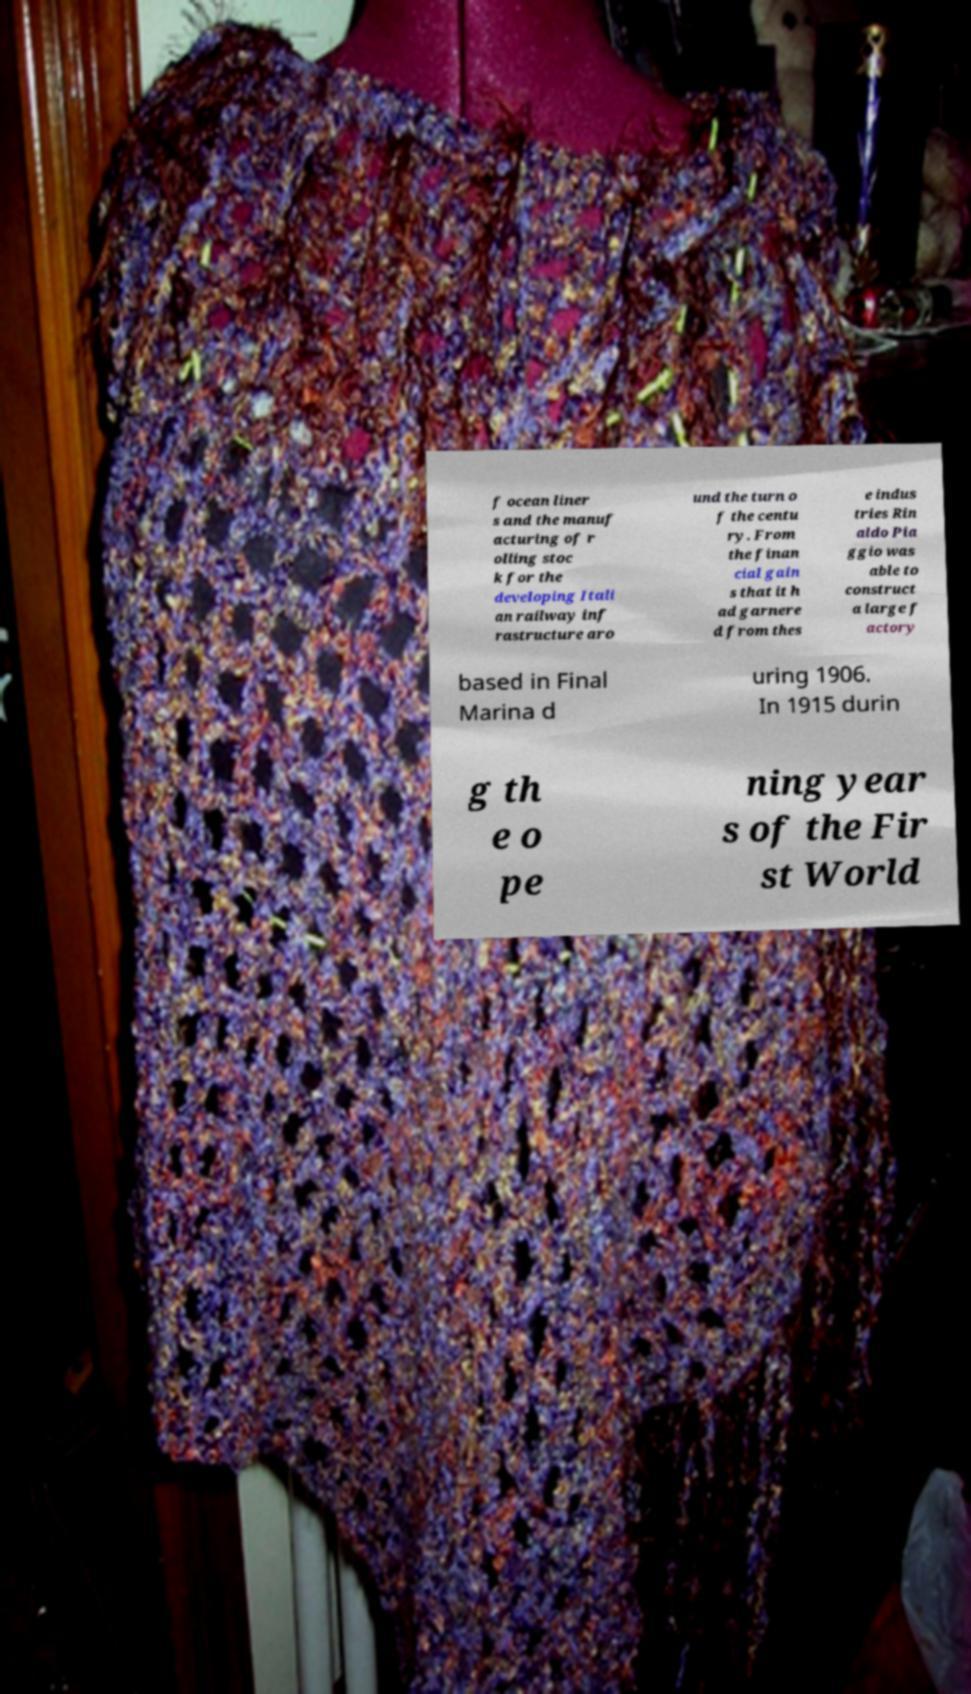I need the written content from this picture converted into text. Can you do that? f ocean liner s and the manuf acturing of r olling stoc k for the developing Itali an railway inf rastructure aro und the turn o f the centu ry. From the finan cial gain s that it h ad garnere d from thes e indus tries Rin aldo Pia ggio was able to construct a large f actory based in Final Marina d uring 1906. In 1915 durin g th e o pe ning year s of the Fir st World 